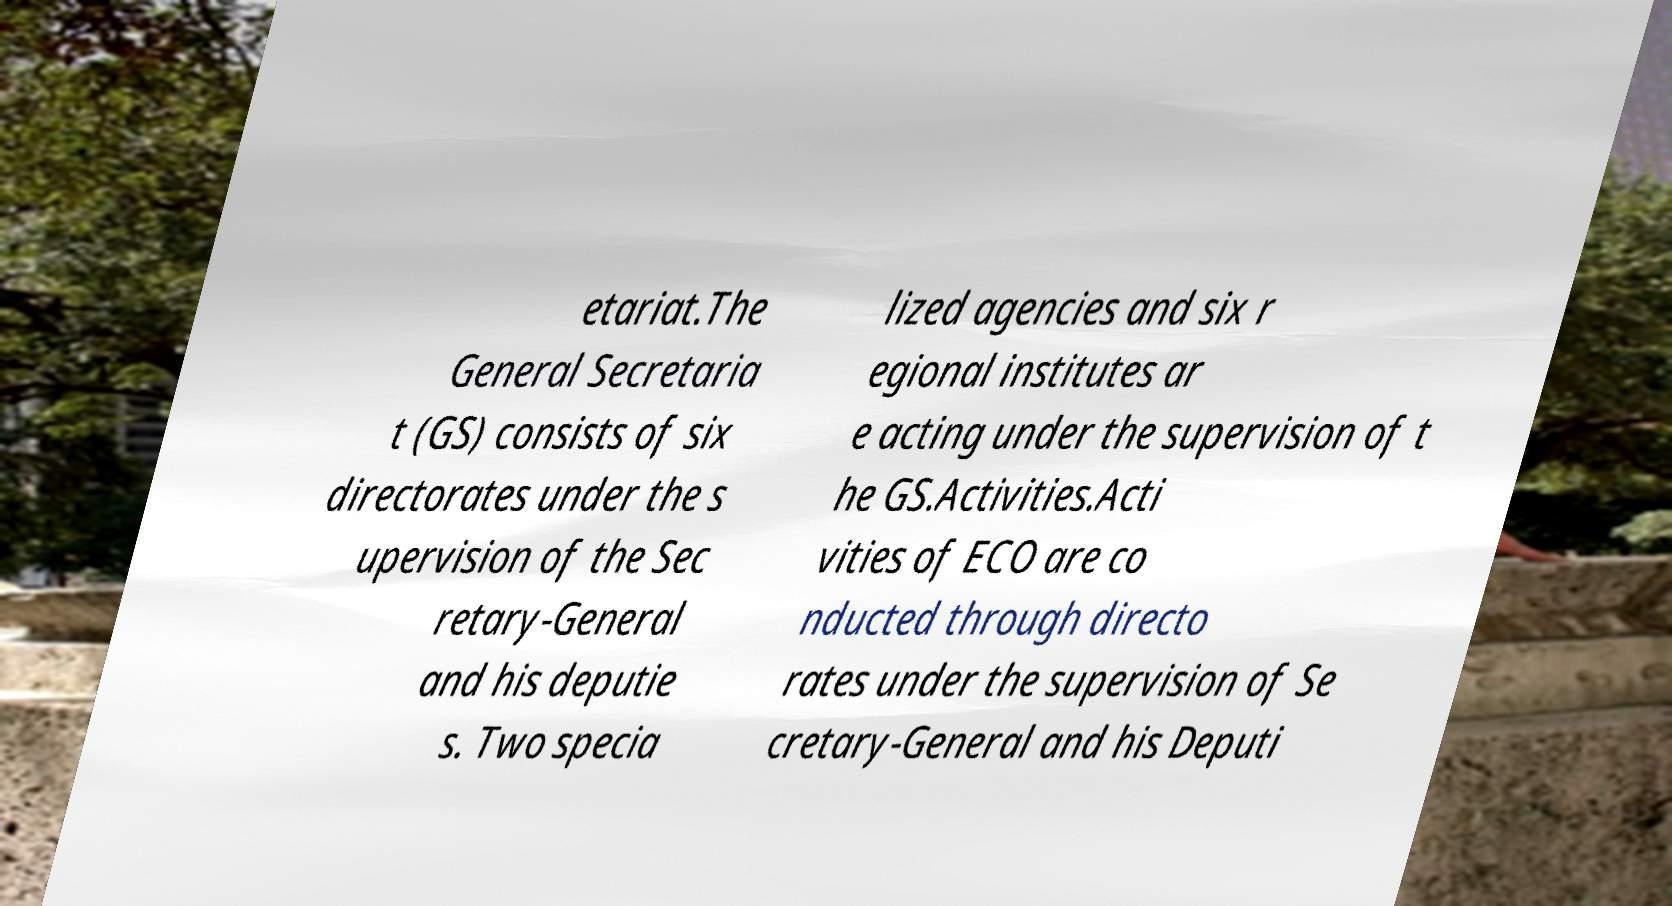Could you assist in decoding the text presented in this image and type it out clearly? etariat.The General Secretaria t (GS) consists of six directorates under the s upervision of the Sec retary-General and his deputie s. Two specia lized agencies and six r egional institutes ar e acting under the supervision of t he GS.Activities.Acti vities of ECO are co nducted through directo rates under the supervision of Se cretary-General and his Deputi 